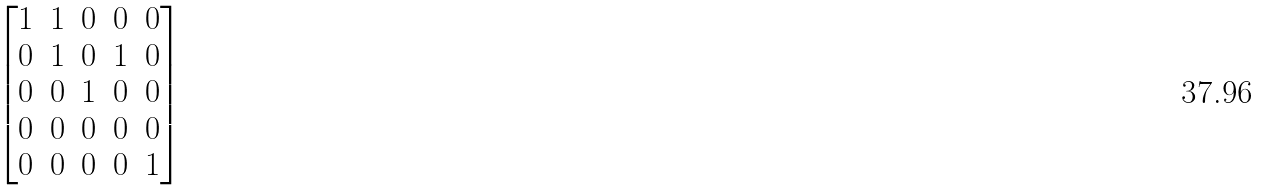<formula> <loc_0><loc_0><loc_500><loc_500>\begin{bmatrix} 1 & 1 & 0 & 0 & 0 \\ 0 & 1 & 0 & 1 & 0 \\ 0 & 0 & 1 & 0 & 0 \\ 0 & 0 & 0 & 0 & 0 \\ 0 & 0 & 0 & 0 & 1 \\ \end{bmatrix}</formula> 